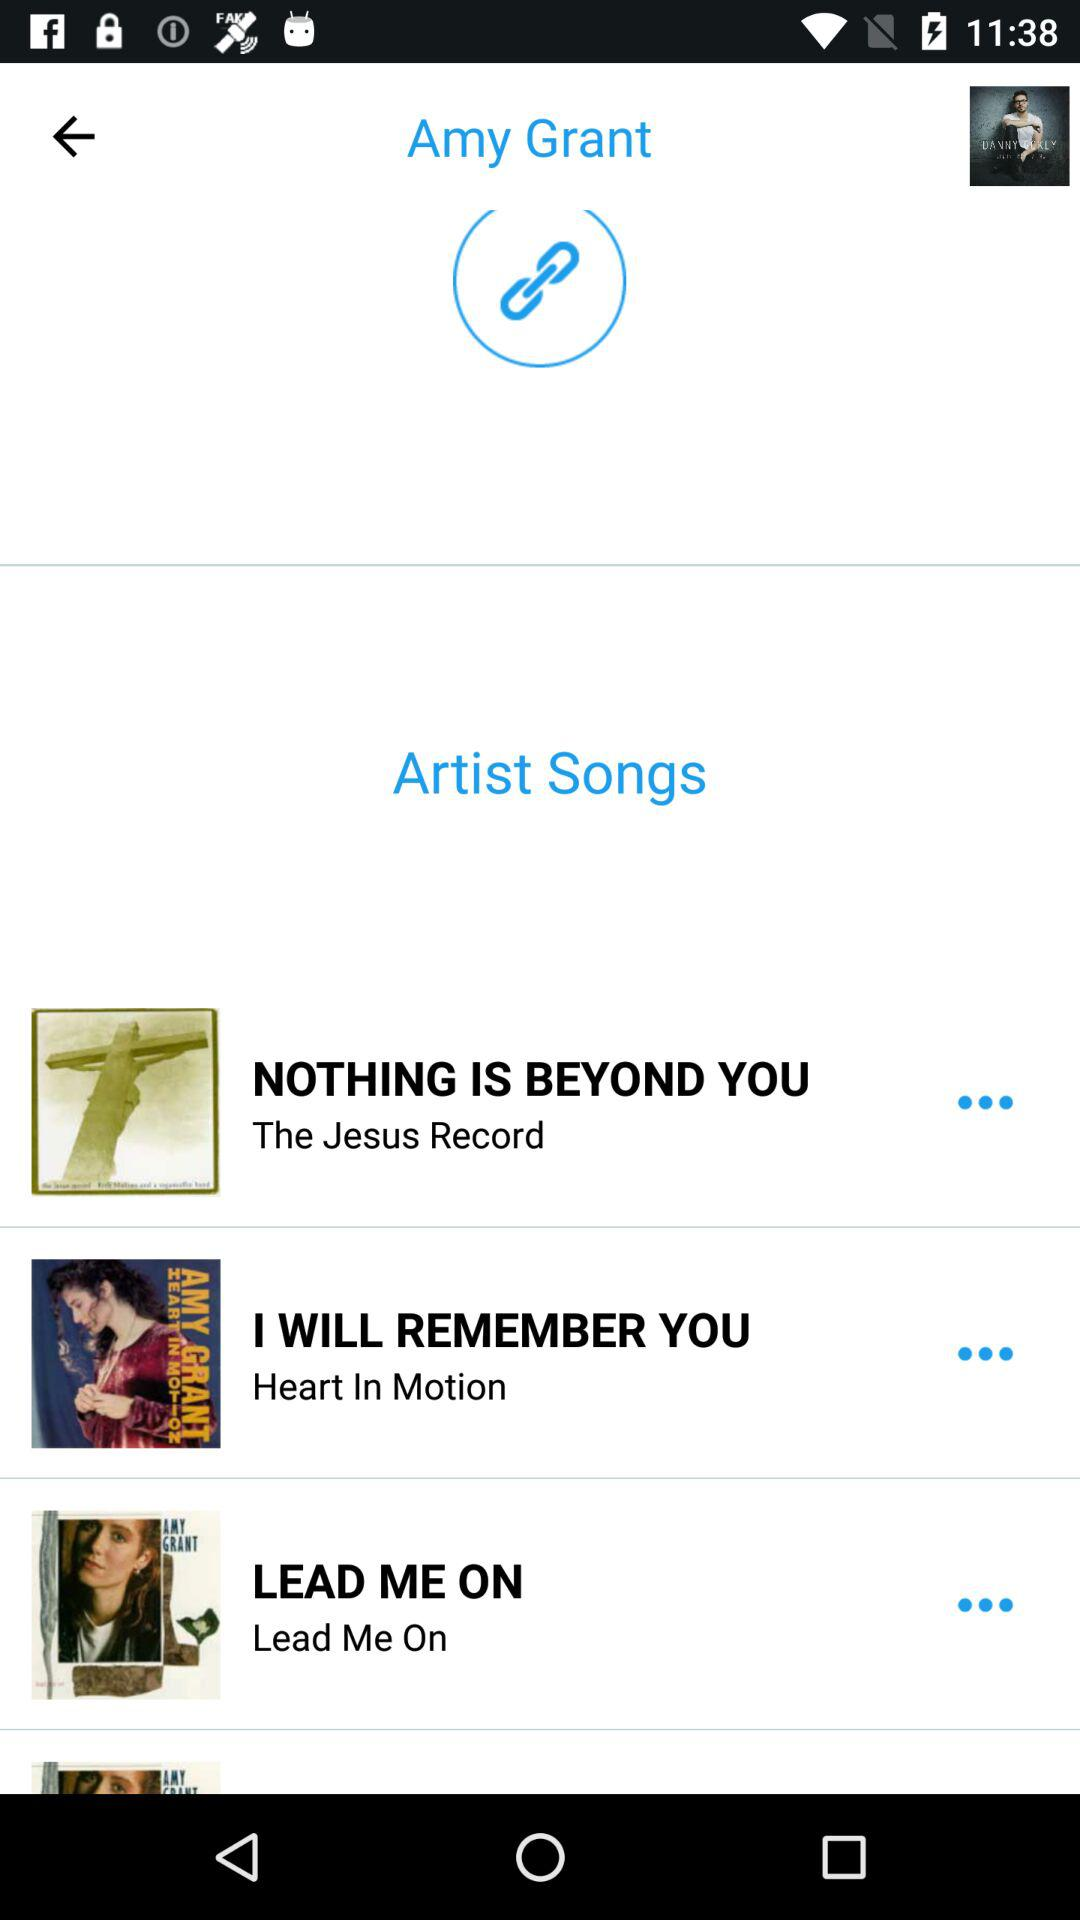How many songs are there by Amy Grant?
Answer the question using a single word or phrase. 3 